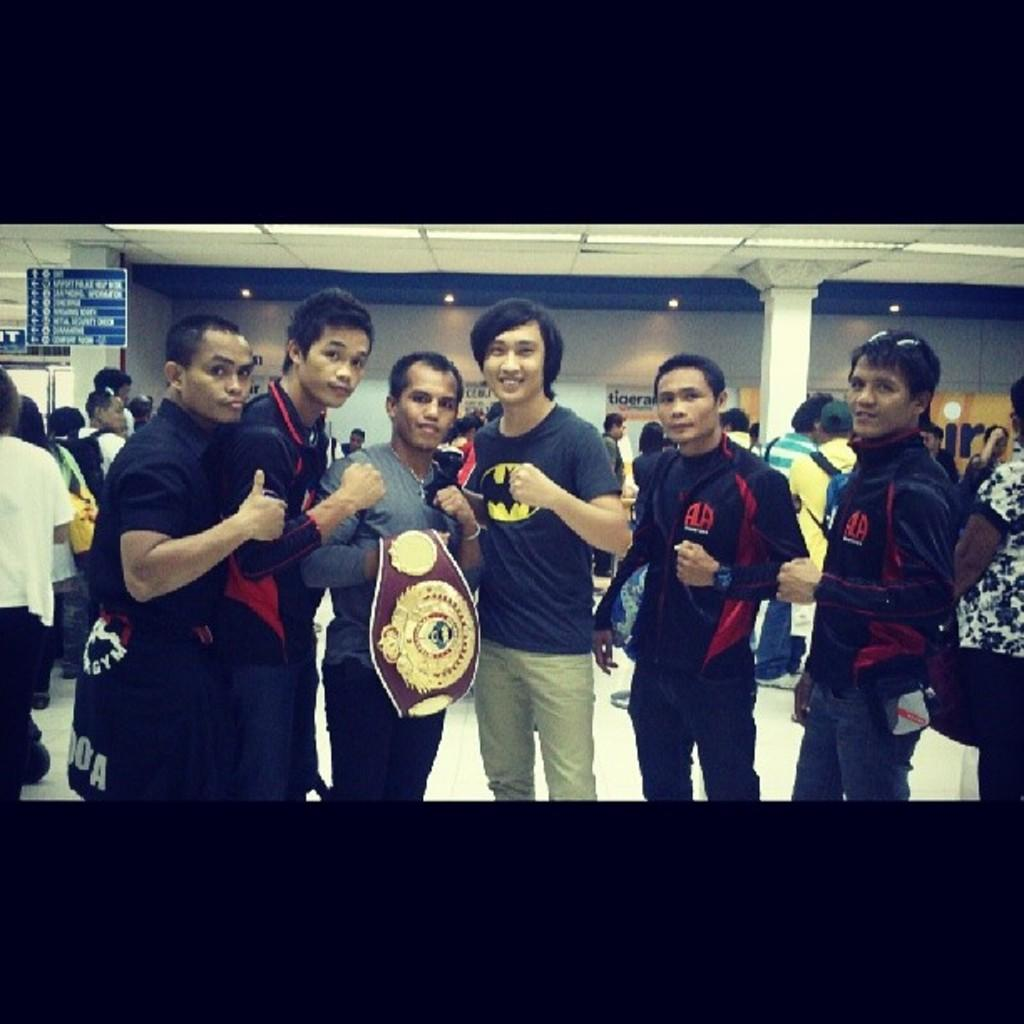Who or what can be seen in the image? There are people in the image. What is the surface beneath the people in the image? The ground is visible in the image. What is on the wall in the image? There is a wall with posters in the image. What is above the people in the image? The roof is visible in the image. What can be seen providing illumination in the image? There are lights in the image. What type of flat, rigid material is present in the image? There are boards in the image. What is the value of the fight between the two people in the image? There is no fight or any indication of conflict between people in the image. 